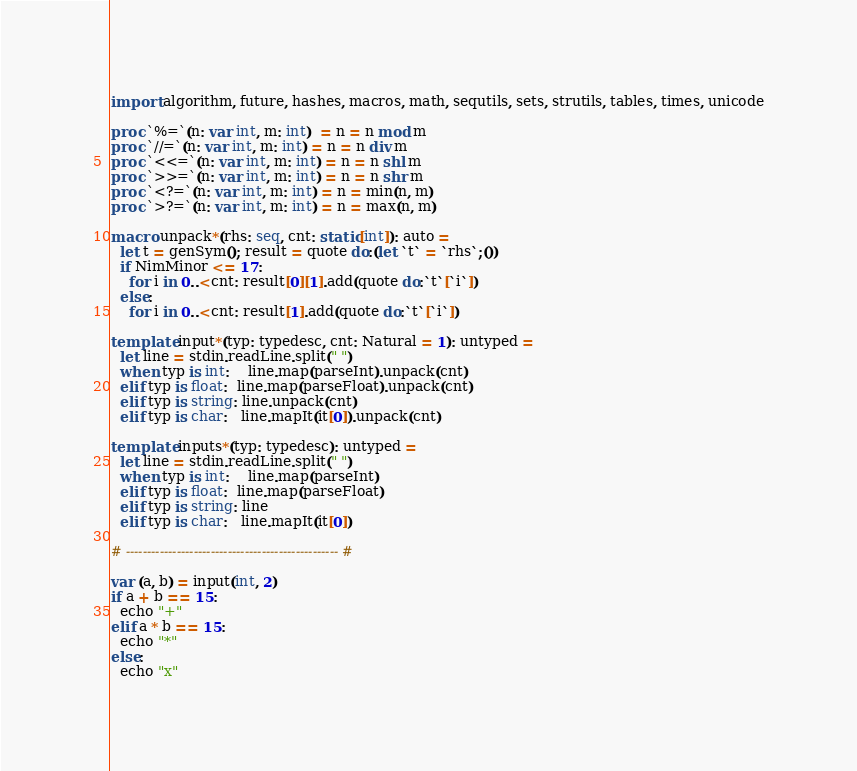Convert code to text. <code><loc_0><loc_0><loc_500><loc_500><_Nim_>import algorithm, future, hashes, macros, math, sequtils, sets, strutils, tables, times, unicode

proc `%=`(n: var int, m: int)  = n = n mod m
proc `//=`(n: var int, m: int) = n = n div m
proc `<<=`(n: var int, m: int) = n = n shl m
proc `>>=`(n: var int, m: int) = n = n shr m
proc `<?=`(n: var int, m: int) = n = min(n, m)
proc `>?=`(n: var int, m: int) = n = max(n, m)

macro unpack*(rhs: seq, cnt: static[int]): auto =
  let t = genSym(); result = quote do:(let `t` = `rhs`;())
  if NimMinor <= 17:
    for i in 0..<cnt: result[0][1].add(quote do:`t`[`i`])
  else:
    for i in 0..<cnt: result[1].add(quote do:`t`[`i`])

template input*(typ: typedesc, cnt: Natural = 1): untyped =
  let line = stdin.readLine.split(" ")
  when typ is int:    line.map(parseInt).unpack(cnt)
  elif typ is float:  line.map(parseFloat).unpack(cnt)
  elif typ is string: line.unpack(cnt)
  elif typ is char:   line.mapIt(it[0]).unpack(cnt)

template inputs*(typ: typedesc): untyped =
  let line = stdin.readLine.split(" ")
  when typ is int:    line.map(parseInt)
  elif typ is float:  line.map(parseFloat)
  elif typ is string: line
  elif typ is char:   line.mapIt(it[0])

# -------------------------------------------------- #

var (a, b) = input(int, 2)
if a + b == 15:
  echo "+"
elif a * b == 15:
  echo "*"
else:
  echo "x"</code> 